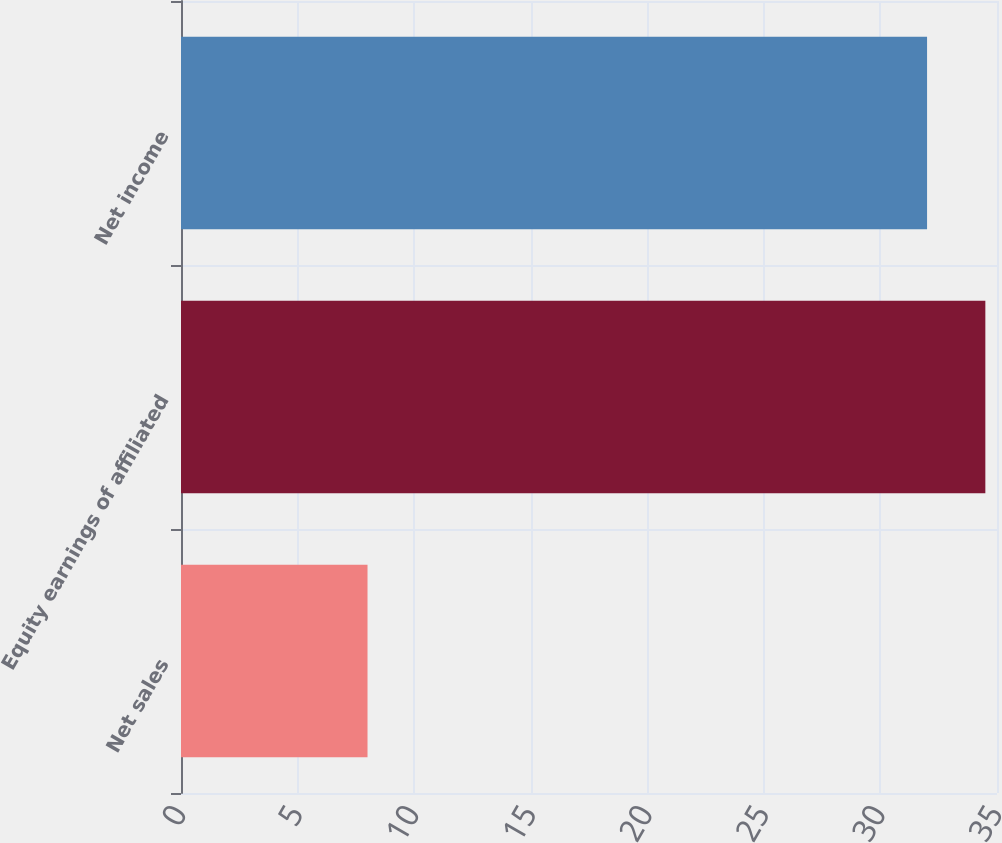Convert chart. <chart><loc_0><loc_0><loc_500><loc_500><bar_chart><fcel>Net sales<fcel>Equity earnings of affiliated<fcel>Net income<nl><fcel>8<fcel>34.5<fcel>32<nl></chart> 